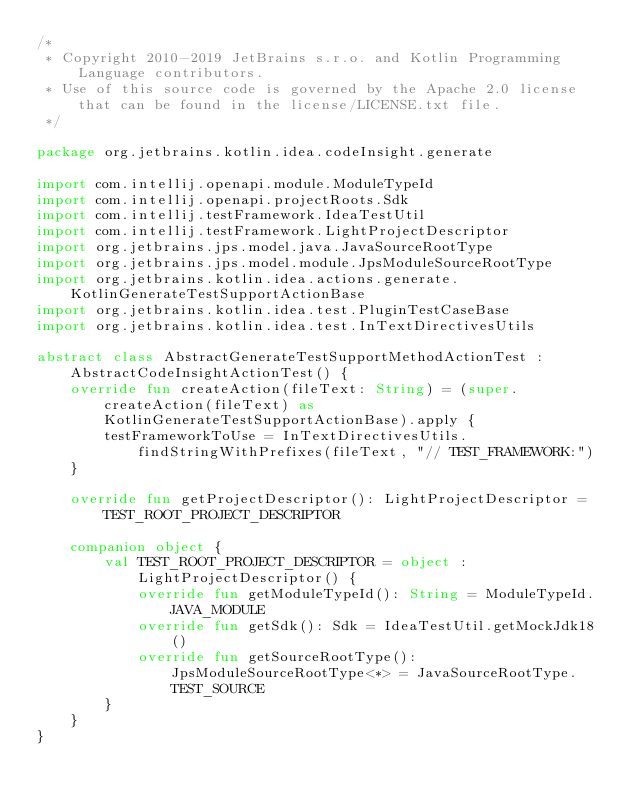<code> <loc_0><loc_0><loc_500><loc_500><_Kotlin_>/*
 * Copyright 2010-2019 JetBrains s.r.o. and Kotlin Programming Language contributors.
 * Use of this source code is governed by the Apache 2.0 license that can be found in the license/LICENSE.txt file.
 */

package org.jetbrains.kotlin.idea.codeInsight.generate

import com.intellij.openapi.module.ModuleTypeId
import com.intellij.openapi.projectRoots.Sdk
import com.intellij.testFramework.IdeaTestUtil
import com.intellij.testFramework.LightProjectDescriptor
import org.jetbrains.jps.model.java.JavaSourceRootType
import org.jetbrains.jps.model.module.JpsModuleSourceRootType
import org.jetbrains.kotlin.idea.actions.generate.KotlinGenerateTestSupportActionBase
import org.jetbrains.kotlin.idea.test.PluginTestCaseBase
import org.jetbrains.kotlin.idea.test.InTextDirectivesUtils

abstract class AbstractGenerateTestSupportMethodActionTest : AbstractCodeInsightActionTest() {
    override fun createAction(fileText: String) = (super.createAction(fileText) as KotlinGenerateTestSupportActionBase).apply {
        testFrameworkToUse = InTextDirectivesUtils.findStringWithPrefixes(fileText, "// TEST_FRAMEWORK:")
    }

    override fun getProjectDescriptor(): LightProjectDescriptor = TEST_ROOT_PROJECT_DESCRIPTOR

    companion object {
        val TEST_ROOT_PROJECT_DESCRIPTOR = object : LightProjectDescriptor() {
            override fun getModuleTypeId(): String = ModuleTypeId.JAVA_MODULE
            override fun getSdk(): Sdk = IdeaTestUtil.getMockJdk18()
            override fun getSourceRootType(): JpsModuleSourceRootType<*> = JavaSourceRootType.TEST_SOURCE
        }
    }
}</code> 